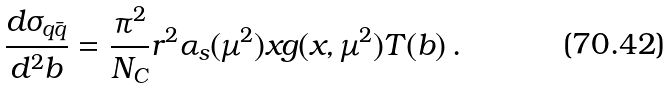Convert formula to latex. <formula><loc_0><loc_0><loc_500><loc_500>\frac { d \sigma _ { q \bar { q } } } { d ^ { 2 } b } = \frac { \pi ^ { 2 } } { N _ { C } } r ^ { 2 } \alpha _ { s } ( \mu ^ { 2 } ) x g ( x , \mu ^ { 2 } ) T ( b ) \, .</formula> 